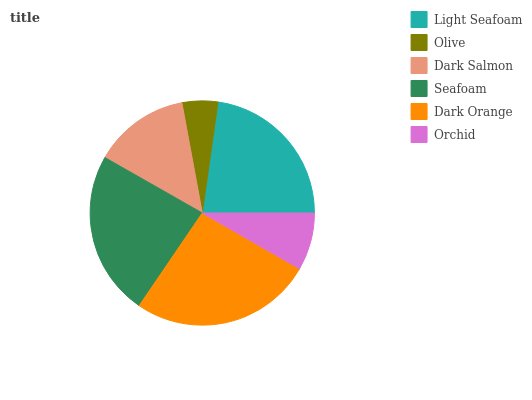Is Olive the minimum?
Answer yes or no. Yes. Is Dark Orange the maximum?
Answer yes or no. Yes. Is Dark Salmon the minimum?
Answer yes or no. No. Is Dark Salmon the maximum?
Answer yes or no. No. Is Dark Salmon greater than Olive?
Answer yes or no. Yes. Is Olive less than Dark Salmon?
Answer yes or no. Yes. Is Olive greater than Dark Salmon?
Answer yes or no. No. Is Dark Salmon less than Olive?
Answer yes or no. No. Is Light Seafoam the high median?
Answer yes or no. Yes. Is Dark Salmon the low median?
Answer yes or no. Yes. Is Seafoam the high median?
Answer yes or no. No. Is Light Seafoam the low median?
Answer yes or no. No. 